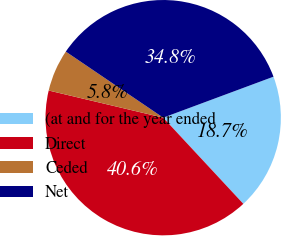Convert chart to OTSL. <chart><loc_0><loc_0><loc_500><loc_500><pie_chart><fcel>(at and for the year ended<fcel>Direct<fcel>Ceded<fcel>Net<nl><fcel>18.74%<fcel>40.63%<fcel>5.78%<fcel>34.85%<nl></chart> 